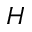<formula> <loc_0><loc_0><loc_500><loc_500>H</formula> 